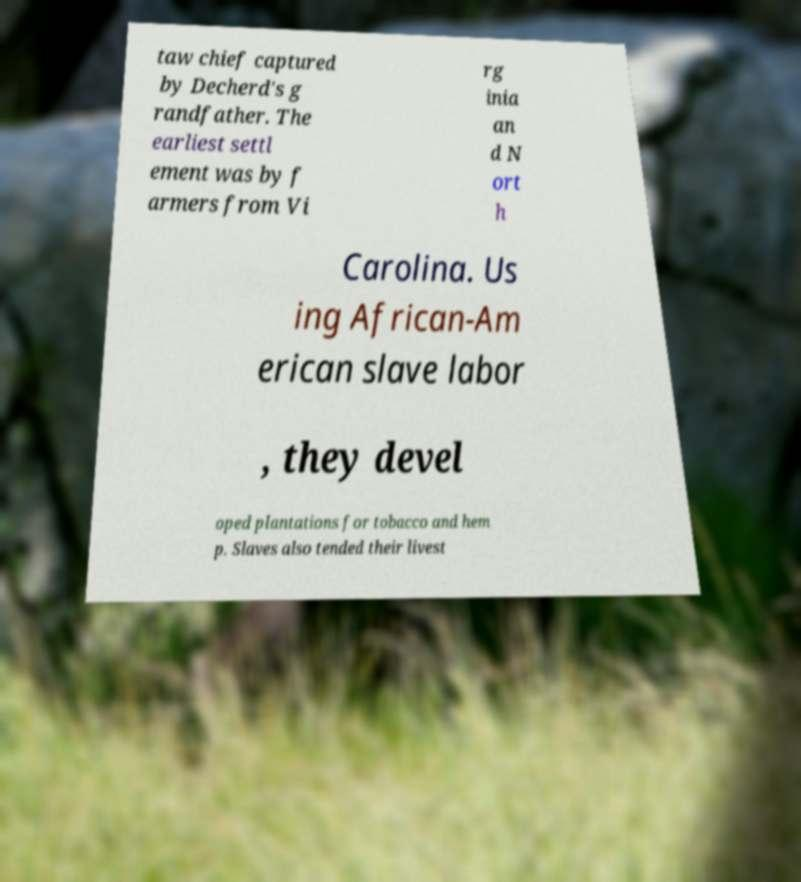For documentation purposes, I need the text within this image transcribed. Could you provide that? taw chief captured by Decherd's g randfather. The earliest settl ement was by f armers from Vi rg inia an d N ort h Carolina. Us ing African-Am erican slave labor , they devel oped plantations for tobacco and hem p. Slaves also tended their livest 